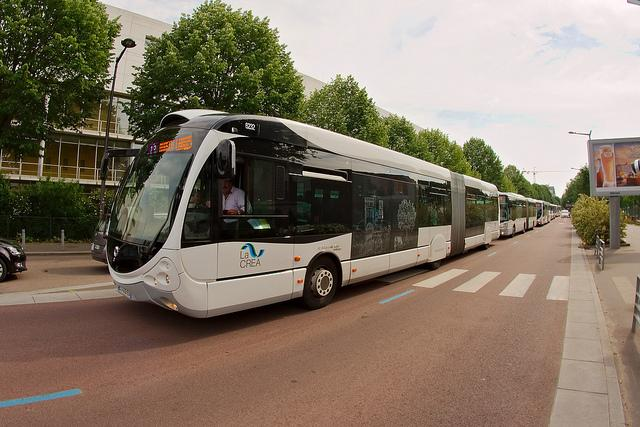What do the white markings on the road allow for here? crossing 